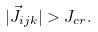Convert formula to latex. <formula><loc_0><loc_0><loc_500><loc_500>| \vec { J } _ { i j k } | > J _ { c r } .</formula> 